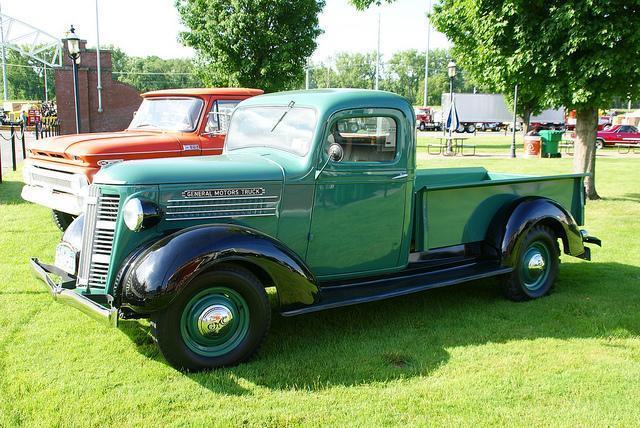How many trucks are in the picture?
Give a very brief answer. 3. How many hot dogs are seen?
Give a very brief answer. 0. 